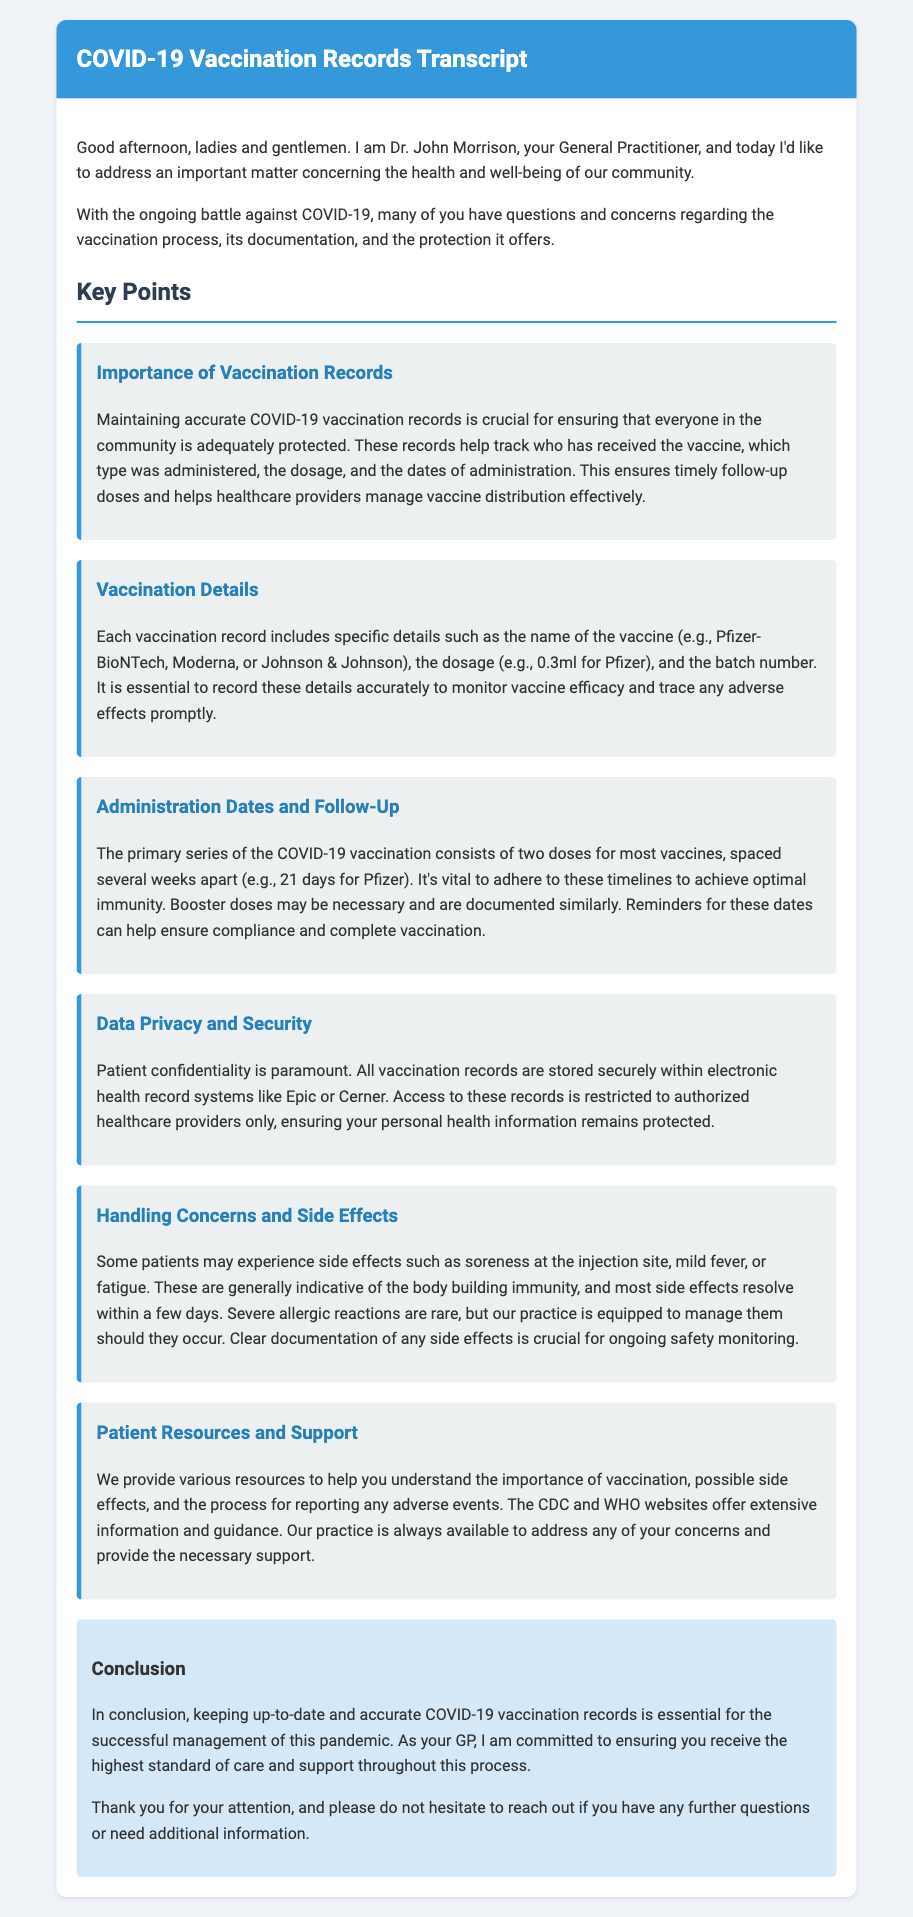What is the importance of vaccination records? The document states that maintaining accurate COVID-19 vaccination records is crucial for ensuring adequate protection and managing vaccine distribution effectively.
Answer: Crucial for ensuring adequate protection What are the names of the vaccines mentioned? The document lists Pfizer-BioNTech, Moderna, and Johnson & Johnson as the vaccines administered.
Answer: Pfizer-BioNTech, Moderna, Johnson & Johnson What is the dosage for the Pfizer vaccine? The document specifies that the dosage for the Pfizer vaccine is 0.3ml.
Answer: 0.3ml How many doses are typically required for primary vaccination? According to the document, the primary series of COVID-19 vaccination consists of two doses for most vaccines.
Answer: Two doses What is the typical gap between the doses for the Pfizer vaccine? The document states that the doses for the Pfizer vaccine are spaced 21 days apart.
Answer: 21 days What type of records are mentioned for data privacy? The document mentions that vaccination records are stored within electronic health record systems like Epic or Cerner.
Answer: Epic or Cerner What are common side effects of the vaccination? The document lists soreness at the injection site, mild fever, or fatigue as common side effects.
Answer: Soreness, mild fever, fatigue What resources are provided to help patients? The document mentions that the CDC and WHO websites offer extensive information and guidance.
Answer: CDC and WHO websites How does the practice handle severe allergic reactions? The document states that the practice is equipped to manage severe allergic reactions should they occur.
Answer: Equipped to manage 